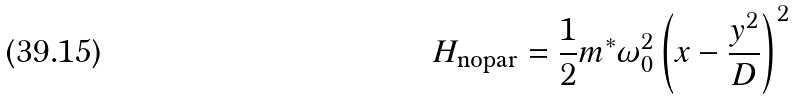<formula> <loc_0><loc_0><loc_500><loc_500>H _ { \text {nopar} } = \frac { 1 } { 2 } m ^ { \ast } \omega _ { 0 } ^ { 2 } \left ( x - \frac { y ^ { 2 } } { D } \right ) ^ { 2 }</formula> 